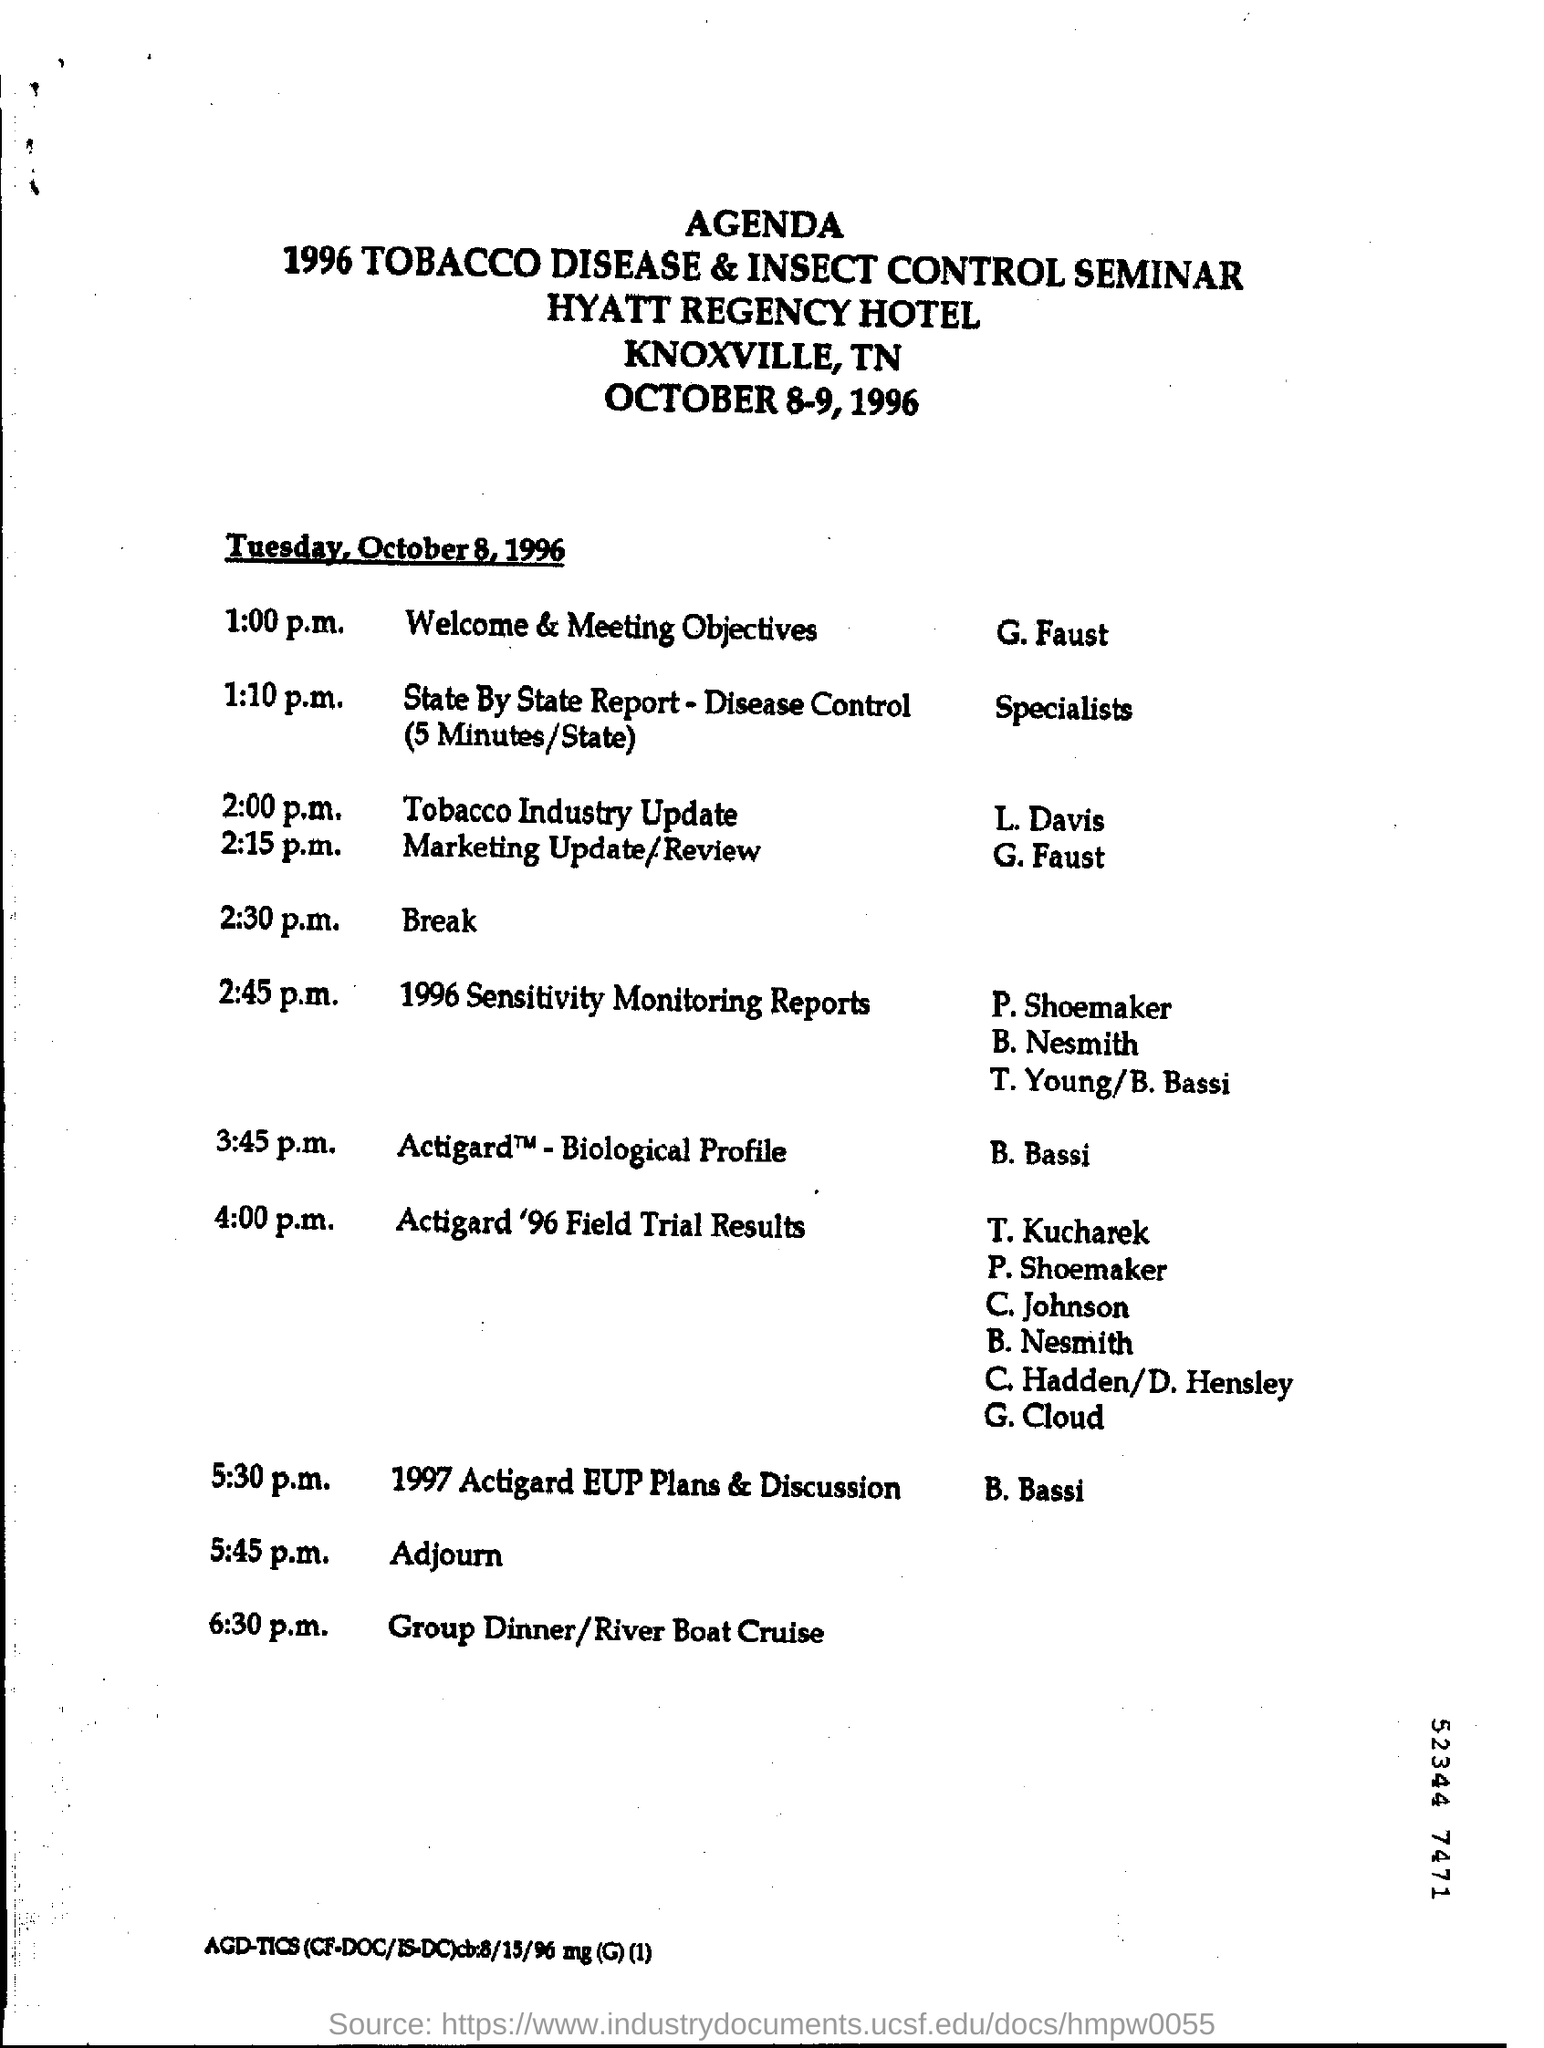Mention a couple of crucial points in this snapshot. The seminar is called "1996 Tobacco Disease & Insect Control. 